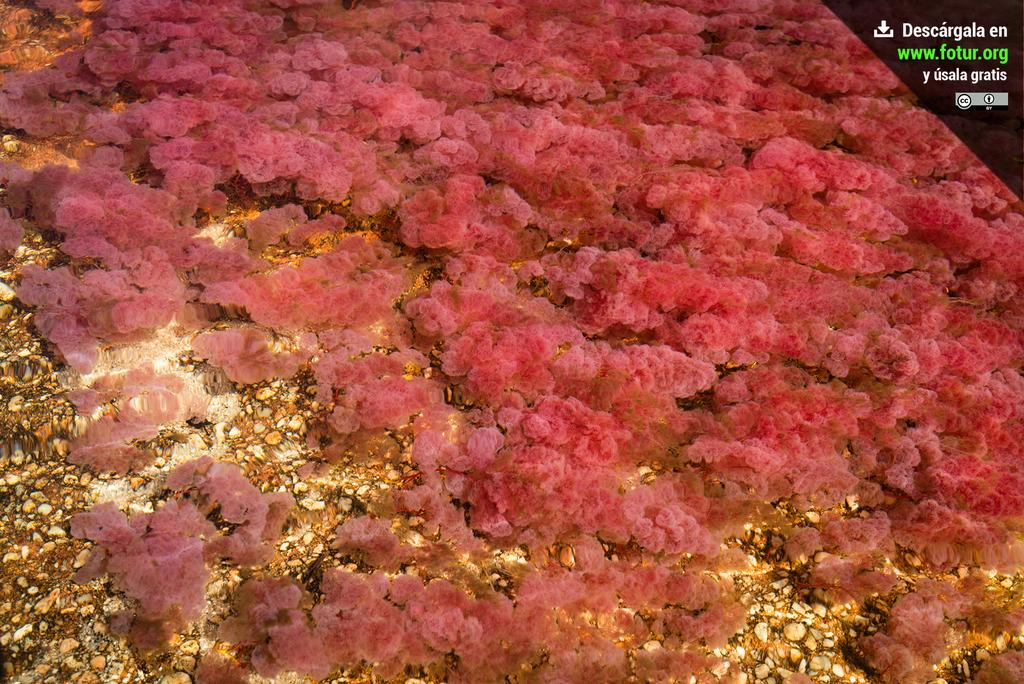What is located in the foreground of the image? There is sea algae in the foreground of the image. Where is the sea algae situated? The sea algae is underwater. What type of alarm can be heard ringing in the image? There is no alarm present in the image, as it features underwater sea algae. 